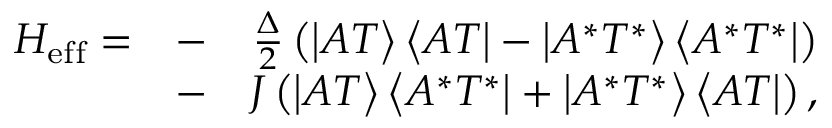Convert formula to latex. <formula><loc_0><loc_0><loc_500><loc_500>\begin{array} { r l r } { H _ { e f f } = } & { - } & { \frac { \Delta } { 2 } \left ( \left | A T \right \rangle \left \langle A T \right | - \left | A ^ { * } T ^ { * } \right \rangle \left \langle A ^ { * } T ^ { * } \right | \right ) } \\ & { - } & { J \left ( \left | A T \right \rangle \left \langle A ^ { * } T ^ { * } \right | + \left | A ^ { * } T ^ { * } \right \rangle \left \langle A T \right | \right ) , } \end{array}</formula> 